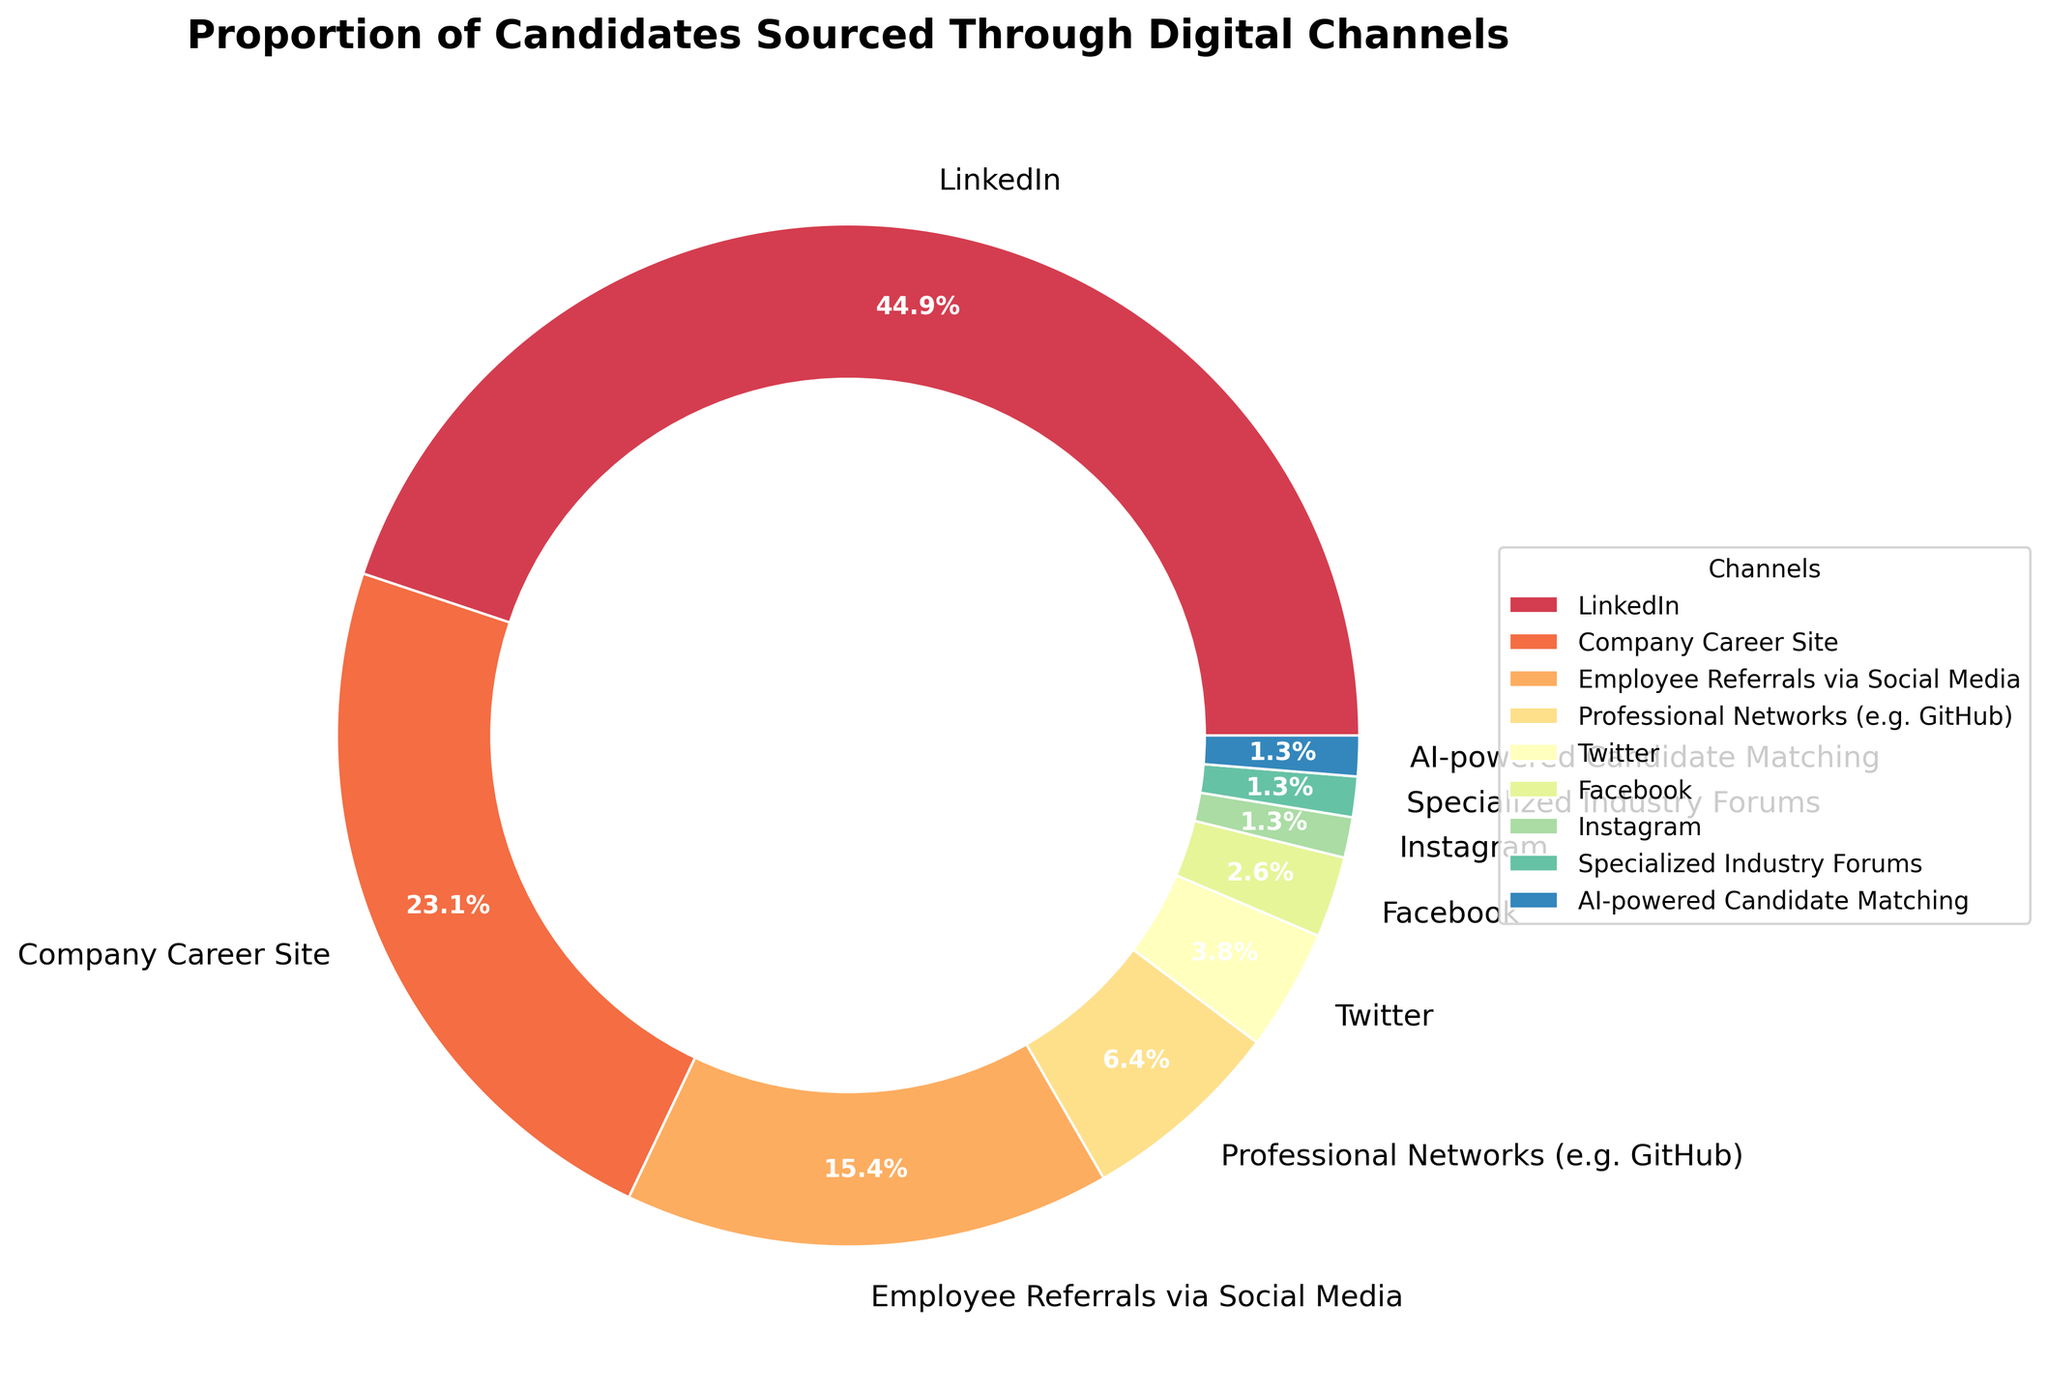What is the most popular channel for sourcing candidates? The largest section of the pie chart is labeled LinkedIn. This section occupies the highest percentage compared to all other sections.
Answer: LinkedIn Which two channels contribute the least to candidate sourcing? The two smallest sections of the pie chart, contributing 1% each, are labeled Specialized Industry Forums and AI-powered Candidate Matching.
Answer: Specialized Industry Forums and AI-powered Candidate Matching How much higher is the percentage of candidates sourced from LinkedIn compared to Company Career Site? LinkedIn accounts for 35% while Company Career Site accounts for 18%. The difference is 35% - 18% = 17%.
Answer: 17% What is the combined percentage of candidates sourced from Instagram, Facebook, and Twitter? The percentages are as follows: Instagram 1%, Facebook 2%, Twitter 3%. Adding these gives 1% + 2% + 3% = 6%.
Answer: 6% Is the proportion of candidates sourced from Employee Referrals via Social Media greater than those sourced from Professional Networks? Employee Referrals via Social Media account for 12%, while Professional Networks account for 5%. Since 12% is greater than 5%, the former is greater.
Answer: Yes Between LinkedIn and all social media channels combined (Twitter, Facebook, Instagram), is LinkedIn still the larger contributor? LinkedIn contributes 35%. Adding social media channels: Twitter 3% + Facebook 2% + Instagram 1% = 6%. LinkedIn (35%) is greater than the combined social media channels (6%).
Answer: Yes Which channels have a percentage smaller than or equal to 5%? The channels with 5% or smaller are Professional Networks (5%), Twitter (3%), Facebook (2%), Instagram (1%), Specialized Industry Forums (1%), and AI-powered Candidate Matching (1%).
Answer: Professional Networks, Twitter, Facebook, Instagram, Specialized Industry Forums, AI-powered Candidate Matching What is the sum of percentages for LinkedIn, Company Career Site, and Employee Referrals via Social Media? The percentages are LinkedIn 35%, Company Career Site 18%, Employee Referrals via Social Media 12%. Adding these gives 35% + 18% + 12% = 65%.
Answer: 65% Is the proportion of candidates sourced from Professional Networks more than triple that of candidates sourced from AI-powered Candidate Matching? Professional Networks has 5%, and AI-powered Candidate Matching has 1%. Triple of 1% is 3%. 5% is greater than 3%, so it is more than triple.
Answer: Yes 